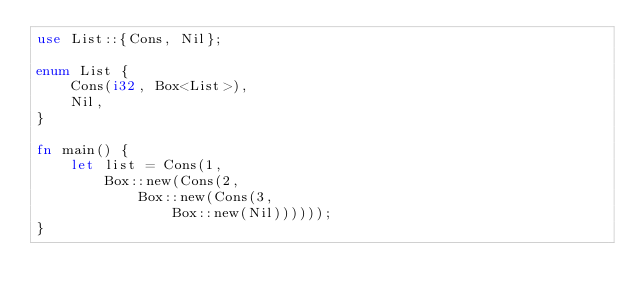<code> <loc_0><loc_0><loc_500><loc_500><_Rust_>use List::{Cons, Nil};

enum List {
    Cons(i32, Box<List>),
    Nil,
}

fn main() {
    let list = Cons(1,
        Box::new(Cons(2,
            Box::new(Cons(3,
                Box::new(Nil))))));
}</code> 